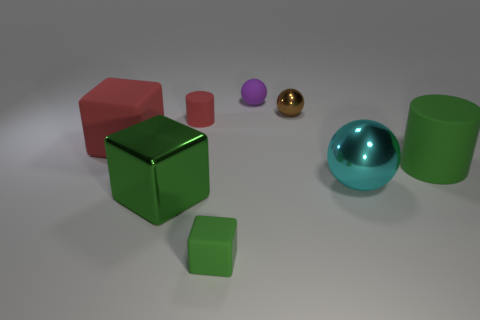What number of things have the same color as the large rubber cylinder?
Your response must be concise. 2. How many large things are either brown cylinders or matte balls?
Offer a very short reply. 0. Is the material of the red thing that is right of the big shiny cube the same as the large ball?
Provide a short and direct response. No. What is the color of the small matte thing that is behind the small metallic ball?
Keep it short and to the point. Purple. Are there any shiny things of the same size as the green rubber block?
Ensure brevity in your answer.  Yes. What material is the sphere that is the same size as the green metal cube?
Your response must be concise. Metal. Does the shiny block have the same size as the rubber cylinder that is to the left of the big green rubber thing?
Ensure brevity in your answer.  No. What is the material of the small object that is in front of the big rubber cube?
Make the answer very short. Rubber. Are there an equal number of tiny red rubber cylinders behind the small red thing and purple matte spheres?
Give a very brief answer. No. Do the purple matte object and the cyan ball have the same size?
Ensure brevity in your answer.  No. 